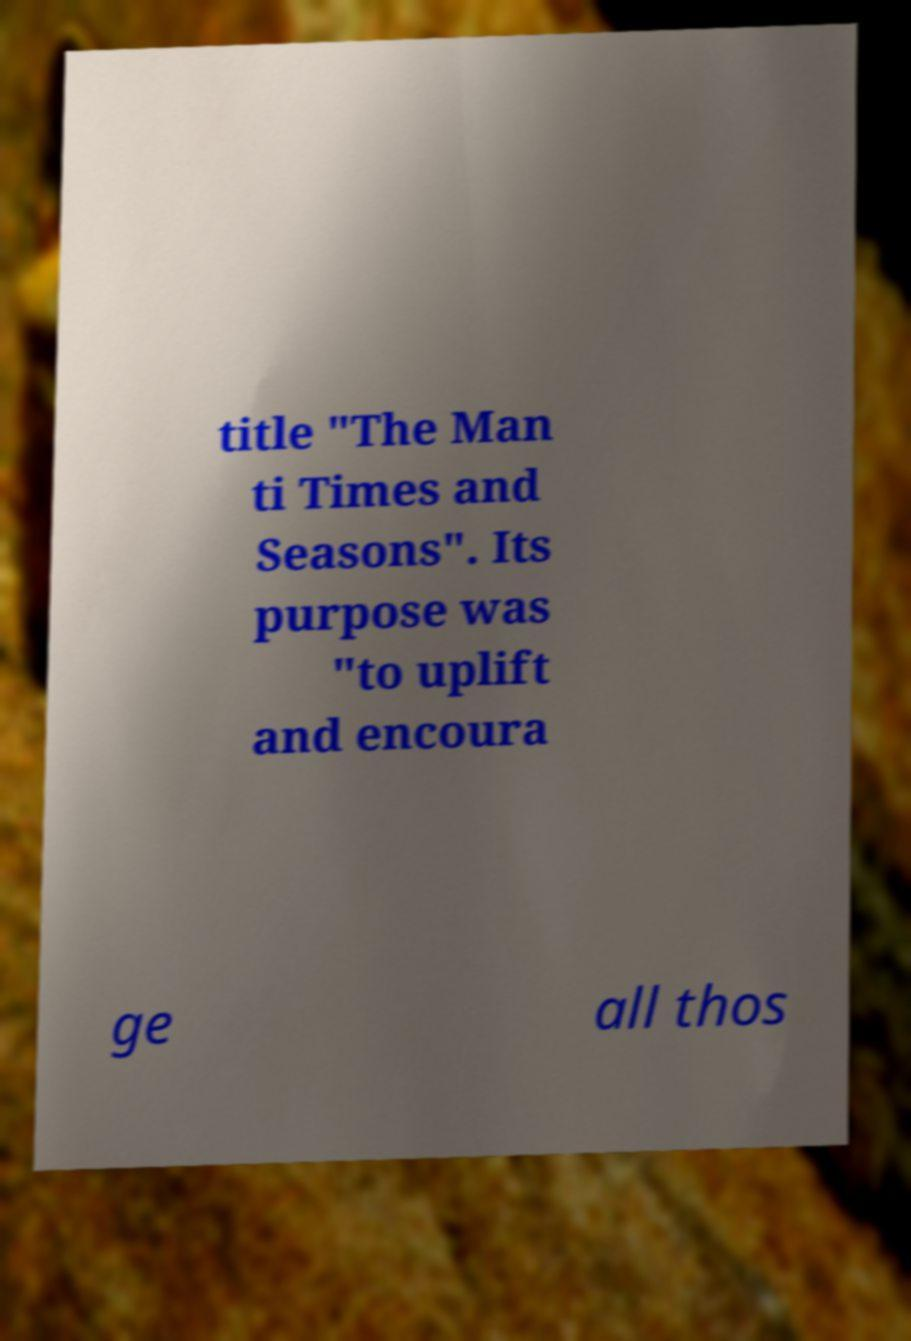I need the written content from this picture converted into text. Can you do that? title "The Man ti Times and Seasons". Its purpose was "to uplift and encoura ge all thos 